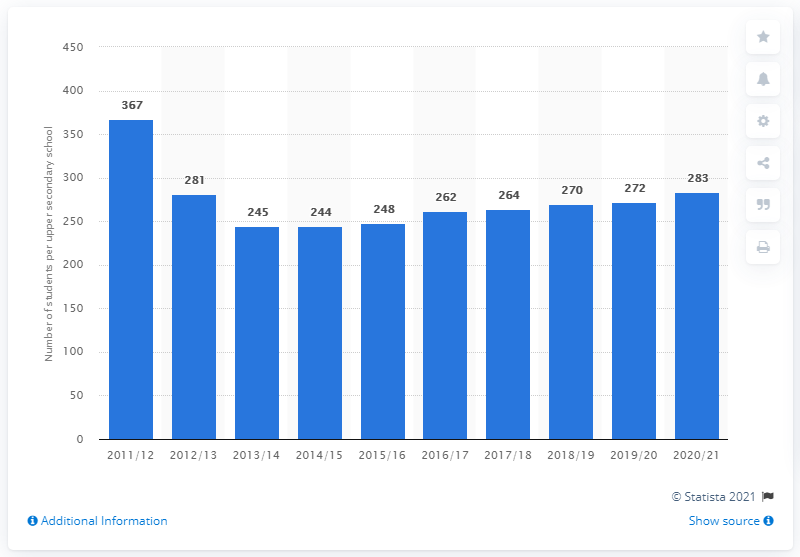Indicate a few pertinent items in this graphic. In the academic year 2011/12, there were 367 students per school on average. There were 283 students per school in the school year 2020/21. 